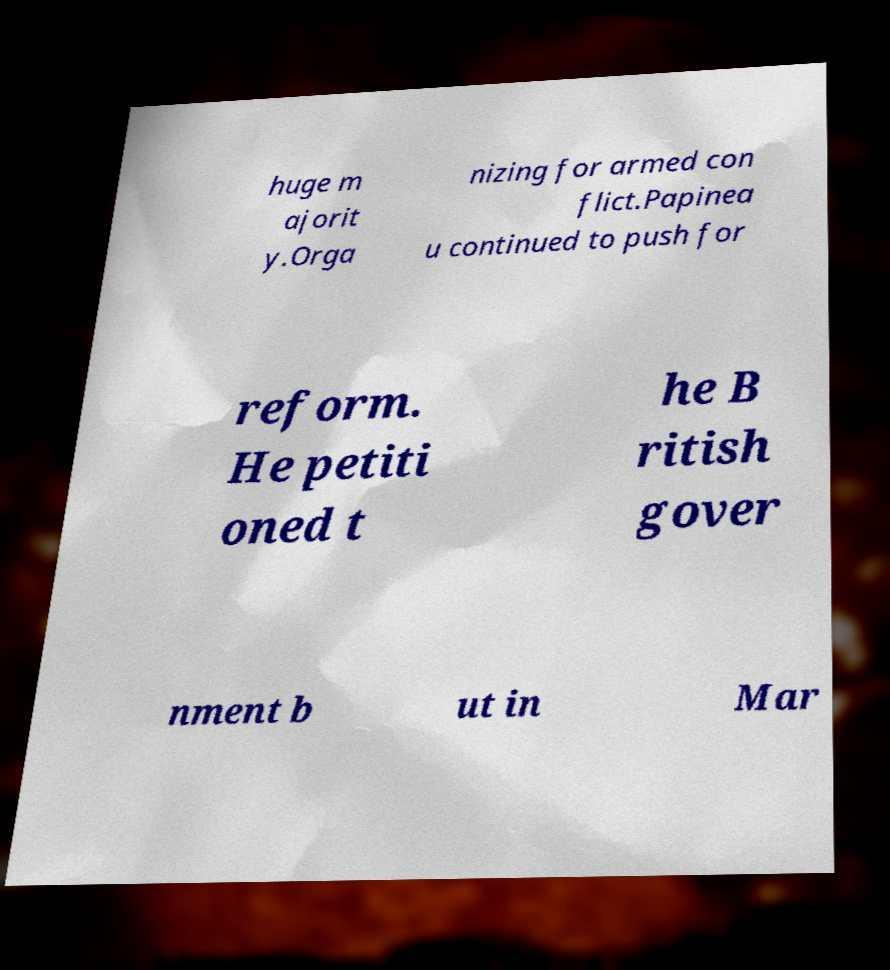Can you accurately transcribe the text from the provided image for me? huge m ajorit y.Orga nizing for armed con flict.Papinea u continued to push for reform. He petiti oned t he B ritish gover nment b ut in Mar 